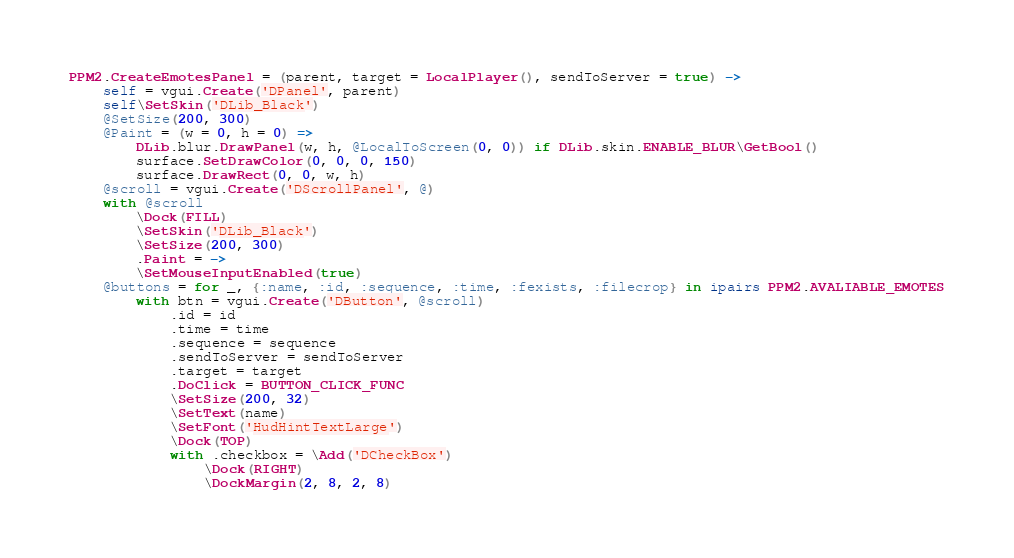Convert code to text. <code><loc_0><loc_0><loc_500><loc_500><_MoonScript_>
PPM2.CreateEmotesPanel = (parent, target = LocalPlayer(), sendToServer = true) ->
	self = vgui.Create('DPanel', parent)
	self\SetSkin('DLib_Black')
	@SetSize(200, 300)
	@Paint = (w = 0, h = 0) =>
		DLib.blur.DrawPanel(w, h, @LocalToScreen(0, 0)) if DLib.skin.ENABLE_BLUR\GetBool()
		surface.SetDrawColor(0, 0, 0, 150)
		surface.DrawRect(0, 0, w, h)
	@scroll = vgui.Create('DScrollPanel', @)
	with @scroll
		\Dock(FILL)
		\SetSkin('DLib_Black')
		\SetSize(200, 300)
		.Paint = ->
		\SetMouseInputEnabled(true)
	@buttons = for _, {:name, :id, :sequence, :time, :fexists, :filecrop} in ipairs PPM2.AVALIABLE_EMOTES
		with btn = vgui.Create('DButton', @scroll)
			.id = id
			.time = time
			.sequence = sequence
			.sendToServer = sendToServer
			.target = target
			.DoClick = BUTTON_CLICK_FUNC
			\SetSize(200, 32)
			\SetText(name)
			\SetFont('HudHintTextLarge')
			\Dock(TOP)
			with .checkbox = \Add('DCheckBox')
				\Dock(RIGHT)
				\DockMargin(2, 8, 2, 8)</code> 